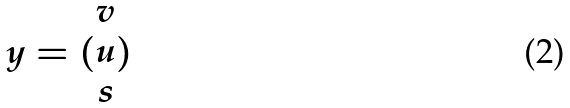Convert formula to latex. <formula><loc_0><loc_0><loc_500><loc_500>y = ( \begin{matrix} v \\ u \\ s \end{matrix} )</formula> 